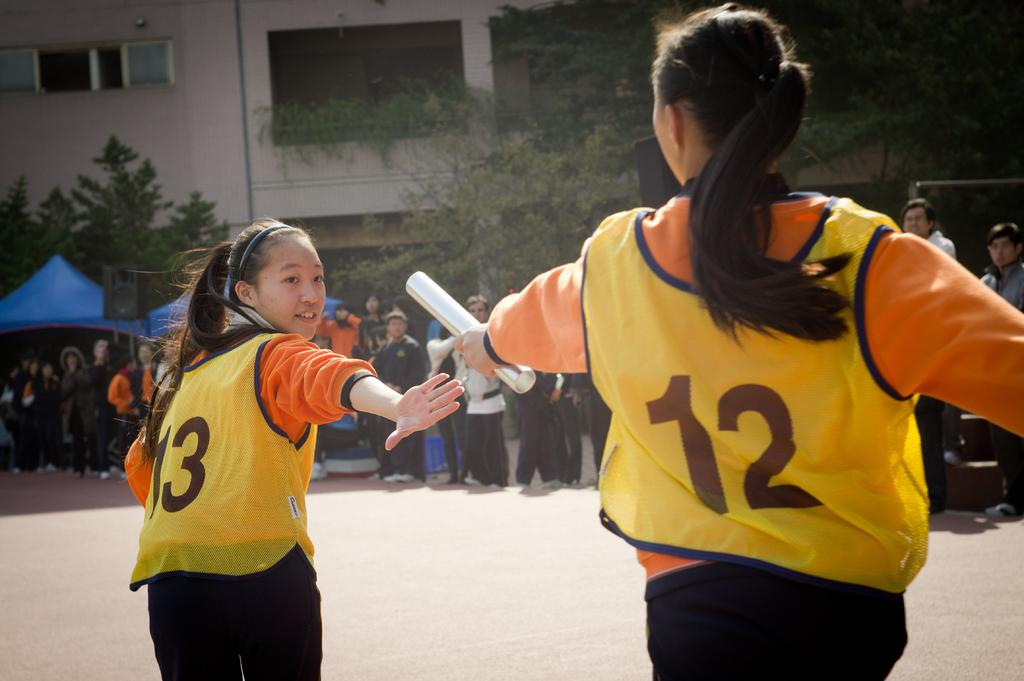Provide a one-sentence caption for the provided image. A runner wearing a jersey with the number 12 hands off a baton to another runner wearing number 13. 